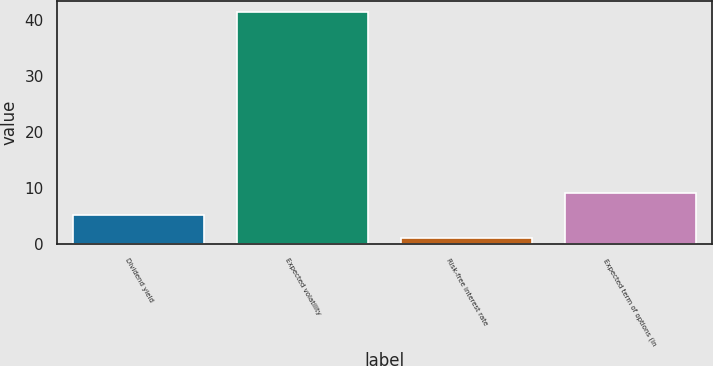Convert chart. <chart><loc_0><loc_0><loc_500><loc_500><bar_chart><fcel>Dividend yield<fcel>Expected volatility<fcel>Risk-free interest rate<fcel>Expected term of options (in<nl><fcel>5.14<fcel>41.42<fcel>1.11<fcel>9.17<nl></chart> 